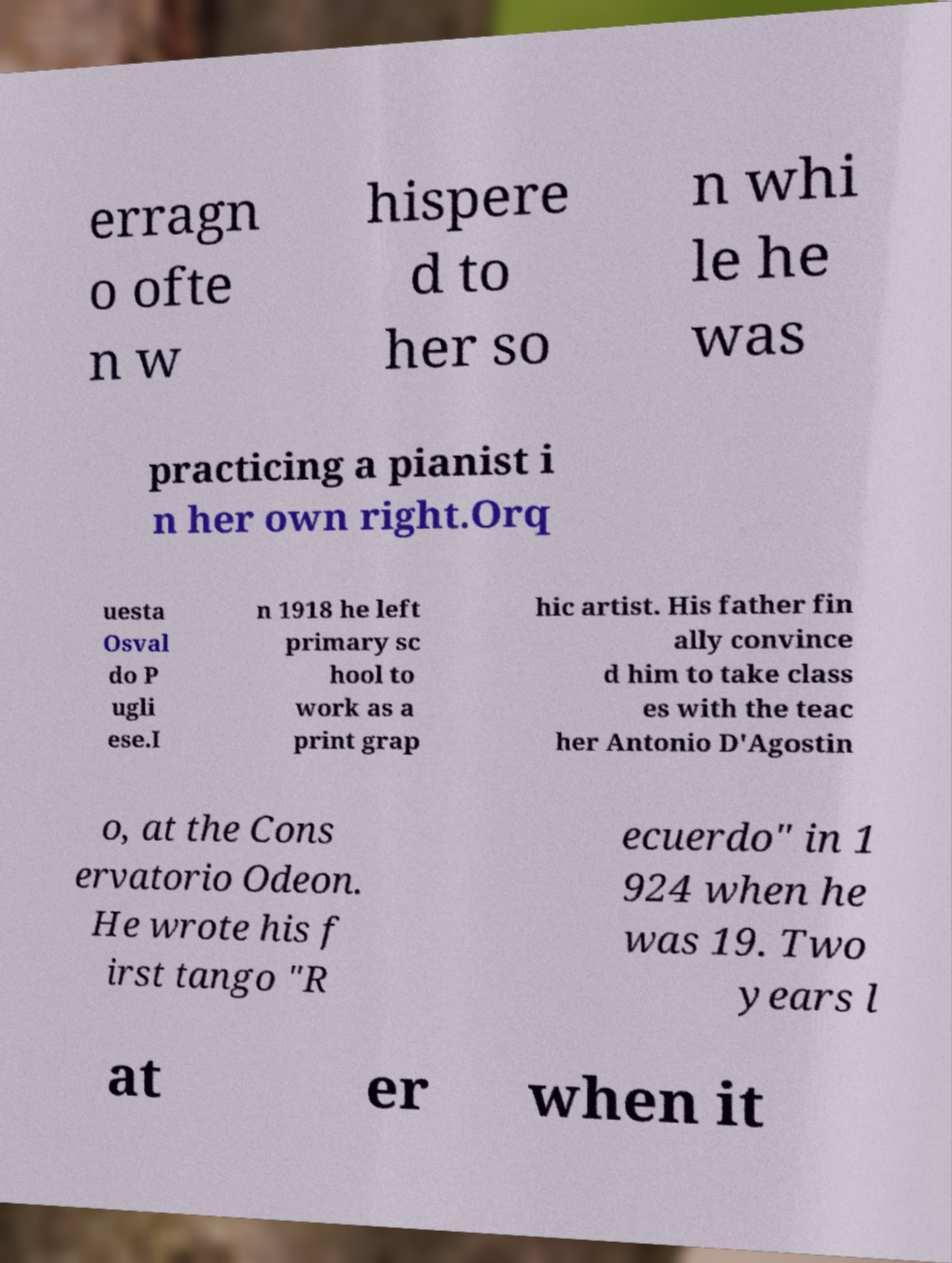Can you accurately transcribe the text from the provided image for me? erragn o ofte n w hispere d to her so n whi le he was practicing a pianist i n her own right.Orq uesta Osval do P ugli ese.I n 1918 he left primary sc hool to work as a print grap hic artist. His father fin ally convince d him to take class es with the teac her Antonio D'Agostin o, at the Cons ervatorio Odeon. He wrote his f irst tango "R ecuerdo" in 1 924 when he was 19. Two years l at er when it 